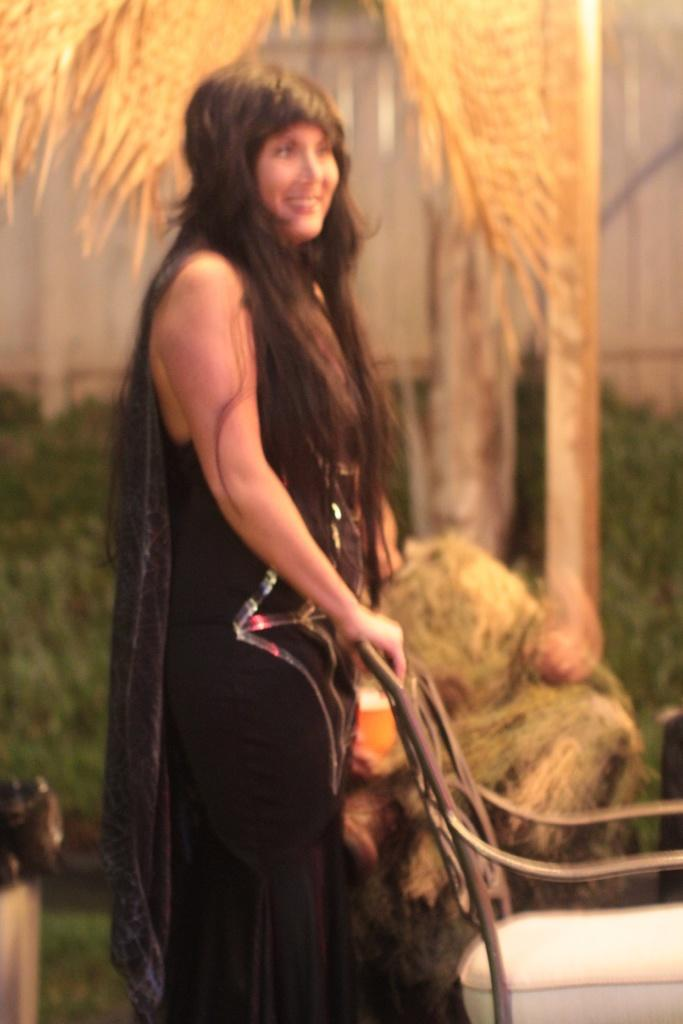Who is present in the image? There is a woman in the image. What is the woman doing in the image? The woman is standing beside a chair. What is the woman wearing in the image? The woman is wearing a black dress. Can you describe the background of the image? The background of the image is blurred. What is the cause of the woman's sudden increase in wealth in the image? There is no indication of wealth or any sudden increase in the image; it only shows a woman standing beside a chair while wearing a black dress. 